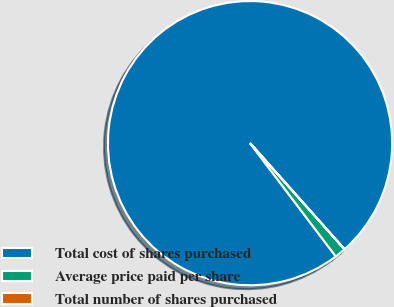<chart> <loc_0><loc_0><loc_500><loc_500><pie_chart><fcel>Total cost of shares purchased<fcel>Average price paid per share<fcel>Total number of shares purchased<nl><fcel>98.73%<fcel>1.26%<fcel>0.01%<nl></chart> 